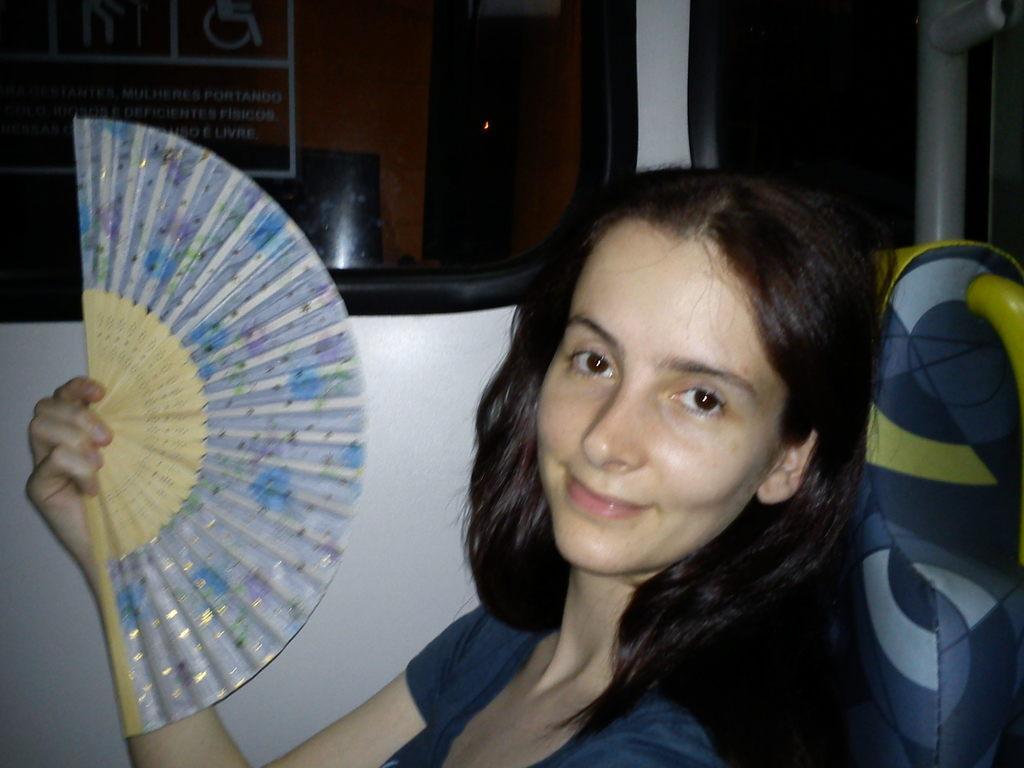Describe this image in one or two sentences. In this picture there is a woman who is holding the paper fan and she is sitting on the seat. At the top I can see the window of the train. In the back I can see the shed. 